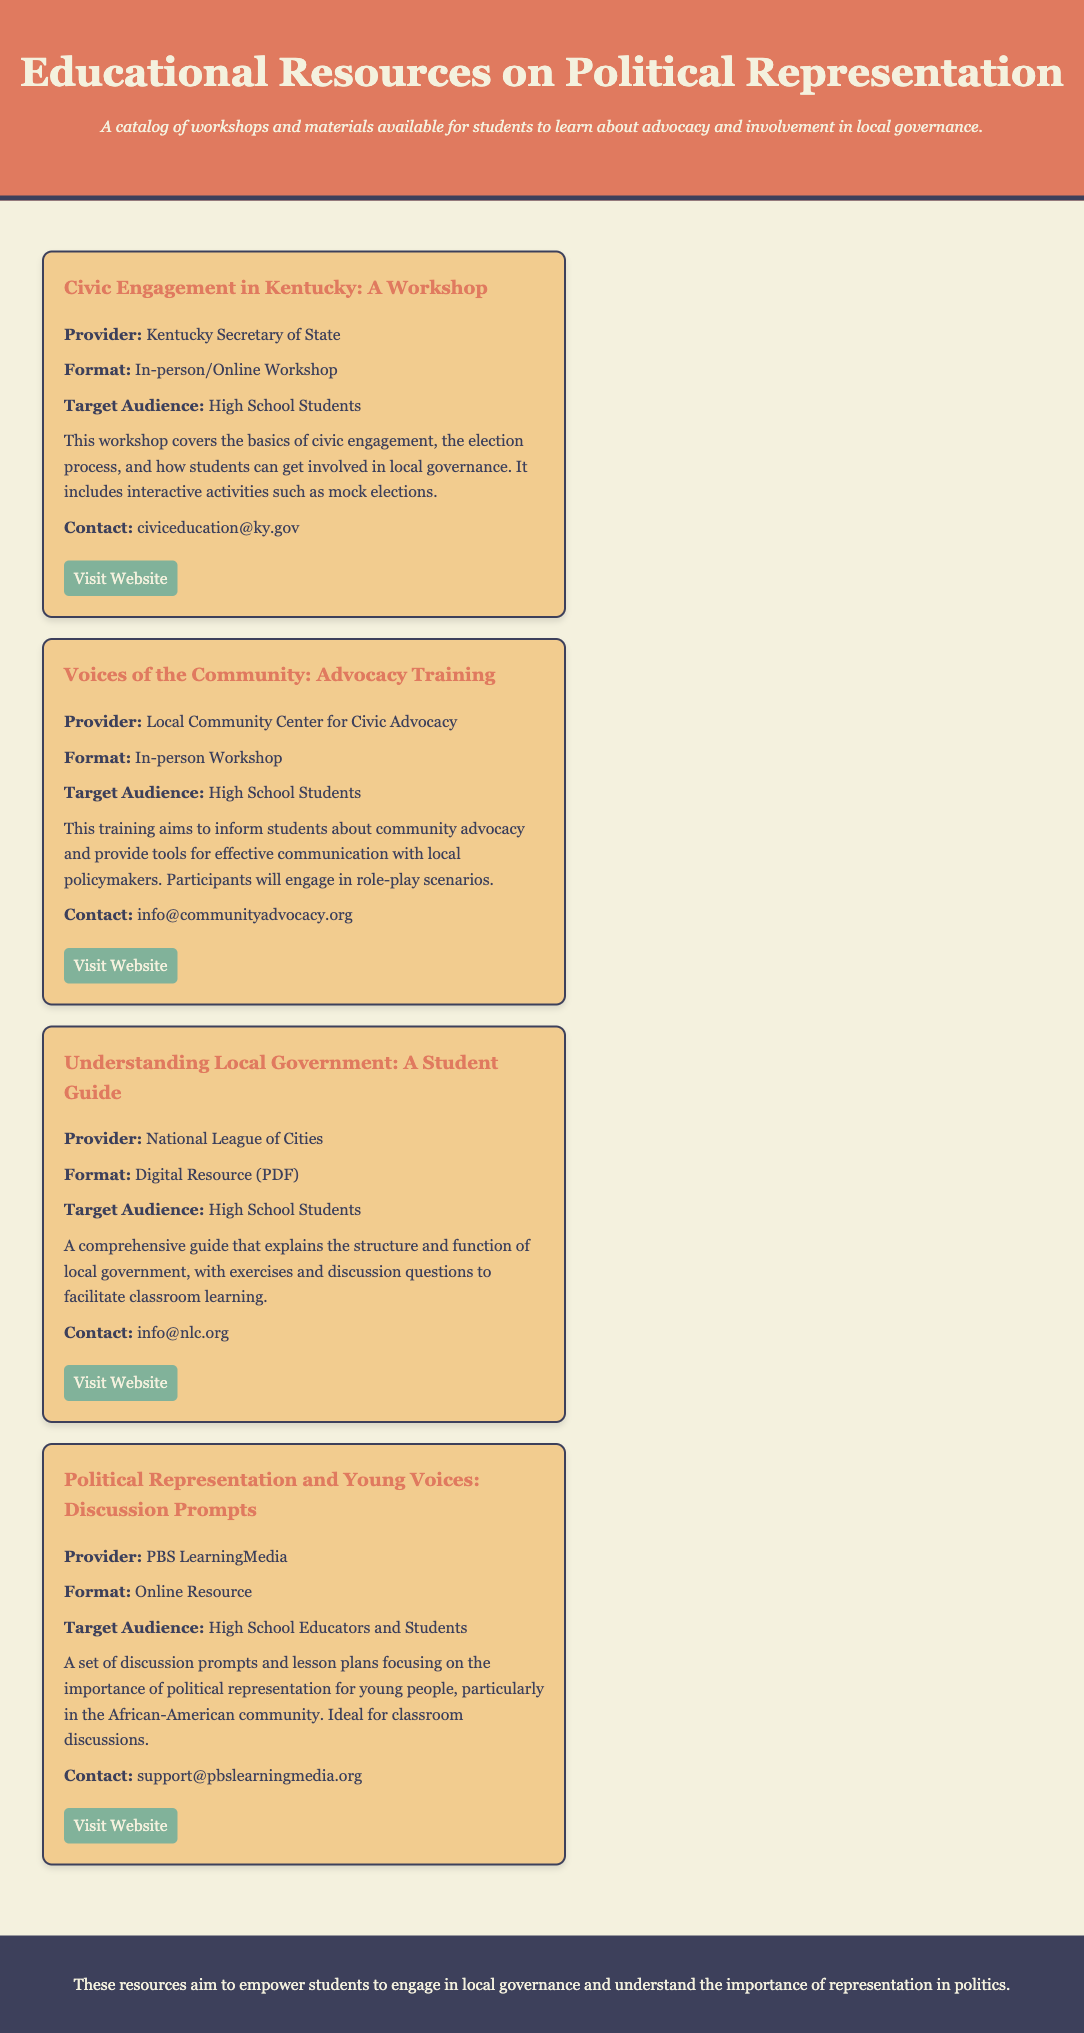What is the title of the first workshop listed? The title of the first workshop is mentioned at the top of its section in the document.
Answer: Civic Engagement in Kentucky: A Workshop Who is the provider of the "Voices of the Community" workshop? The provider is listed right below the title of the workshop.
Answer: Local Community Center for Civic Advocacy What type of resource is the "Understanding Local Government"? The format is specified in the description of the resource.
Answer: Digital Resource (PDF) What is the target audience for the "Political Representation and Young Voices" resource? The target audience is clearly stated in the document for each resource.
Answer: High School Educators and Students How can participants communicate with the Kentucky Secretary of State for more information on the workshop? The contact information is provided at the end of each resource section.
Answer: civiceducation@ky.gov What activity is included in the "Civic Engagement in Kentucky" workshop? The document describes what interactive activities are included within the workshop.
Answer: Mock elections Which organization provided the discussion prompts focusing on political representation? The provider is mentioned in the title section of the resource.
Answer: PBS LearningMedia What is the main purpose of the resources listed in the document? This information is summarized in the footer section of the document.
Answer: Empower students to engage in local governance and understand the importance of representation in politics 